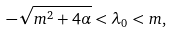<formula> <loc_0><loc_0><loc_500><loc_500>- \sqrt { m ^ { 2 } + 4 \alpha } < \lambda _ { 0 } < m ,</formula> 